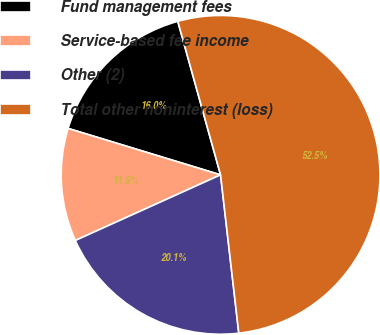Convert chart to OTSL. <chart><loc_0><loc_0><loc_500><loc_500><pie_chart><fcel>Fund management fees<fcel>Service-based fee income<fcel>Other (2)<fcel>Total other noninterest (loss)<nl><fcel>15.97%<fcel>11.46%<fcel>20.07%<fcel>52.5%<nl></chart> 